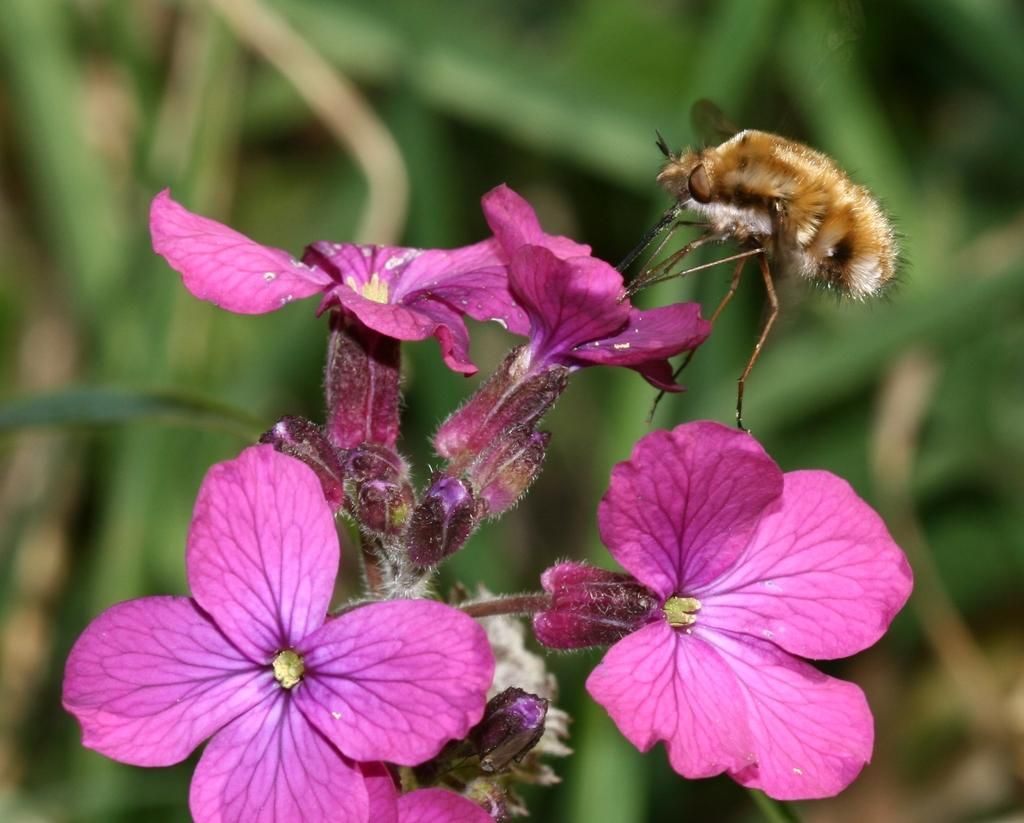What type of creature can be seen in the image? There is an insect in the image. What other natural elements are present in the image? There are flowers in the image. What can be seen in the background of the image? There are leaves in the background of the image. How would you describe the clarity of the image? The image is blurry. How many people are in the crowd in the image? There is no crowd present in the image; it features an insect, flowers, and leaves. What type of brick is visible in the image? There is no brick present in the image. 